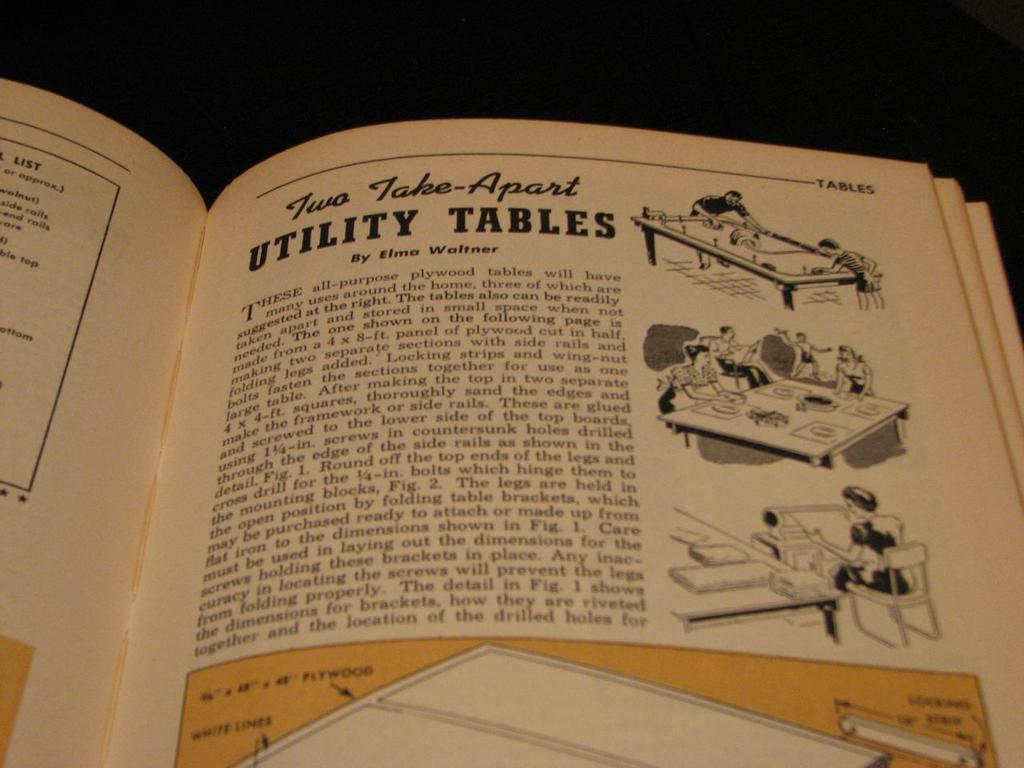How would you summarize this image in a sentence or two? In this image I can see a book which is cream, black and yellow in color. I can see few pictures of persons standing and a person sitting and I can see the black colored background. 